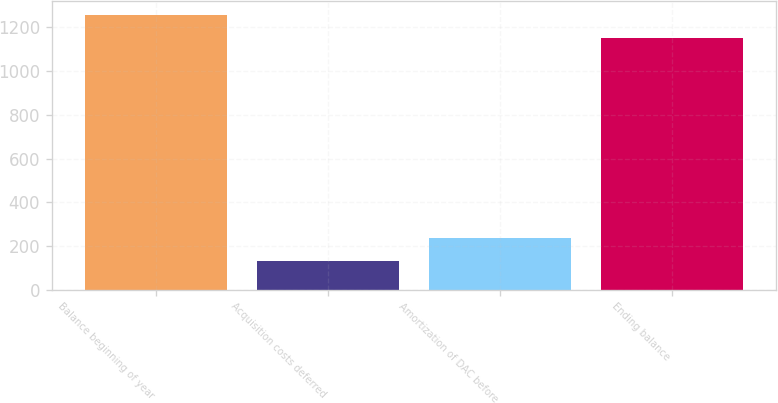Convert chart. <chart><loc_0><loc_0><loc_500><loc_500><bar_chart><fcel>Balance beginning of year<fcel>Acquisition costs deferred<fcel>Amortization of DAC before<fcel>Ending balance<nl><fcel>1258.8<fcel>132<fcel>238.8<fcel>1152<nl></chart> 